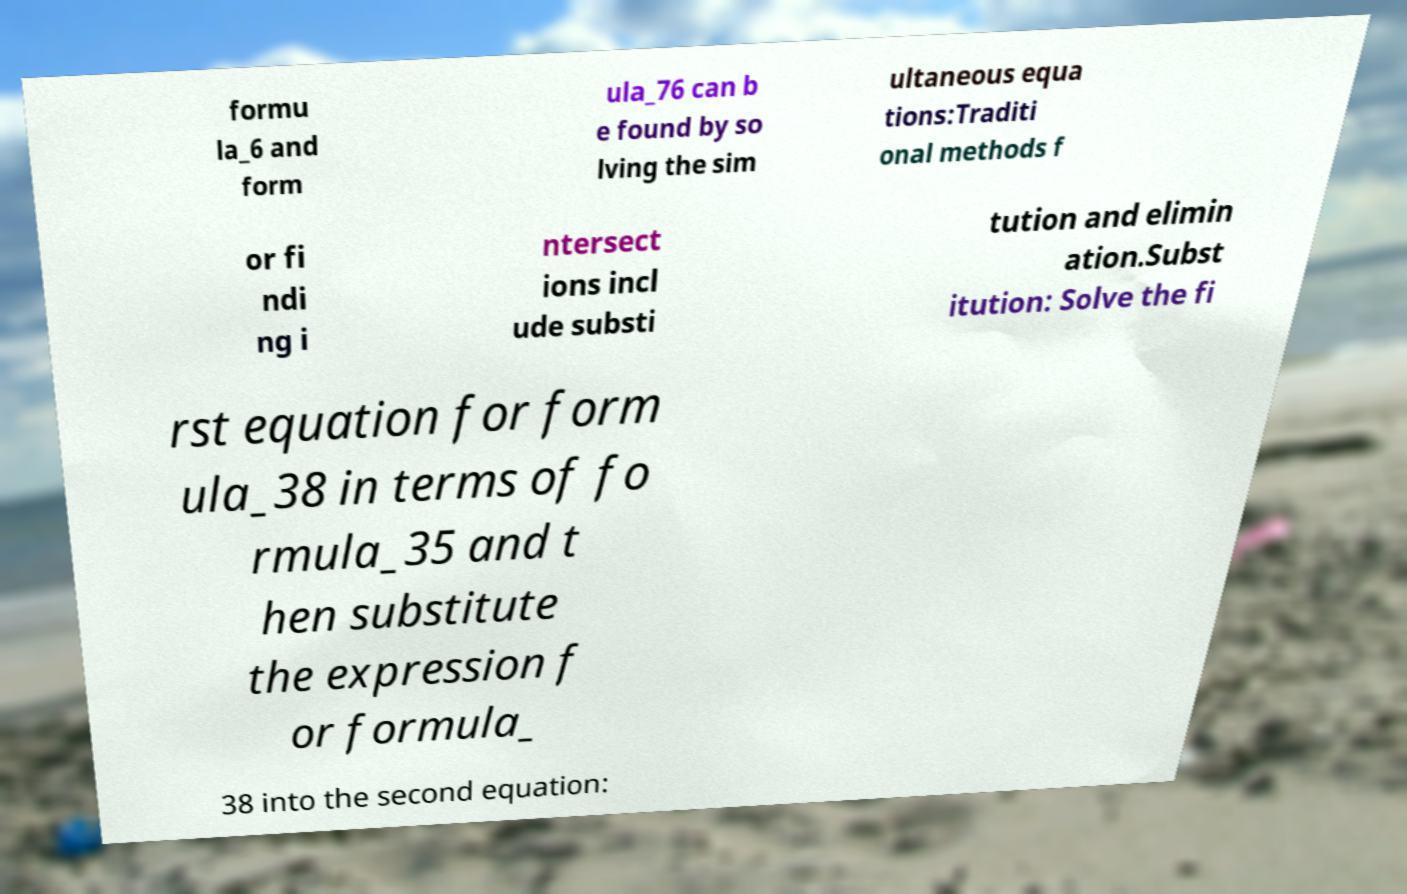What messages or text are displayed in this image? I need them in a readable, typed format. formu la_6 and form ula_76 can b e found by so lving the sim ultaneous equa tions:Traditi onal methods f or fi ndi ng i ntersect ions incl ude substi tution and elimin ation.Subst itution: Solve the fi rst equation for form ula_38 in terms of fo rmula_35 and t hen substitute the expression f or formula_ 38 into the second equation: 